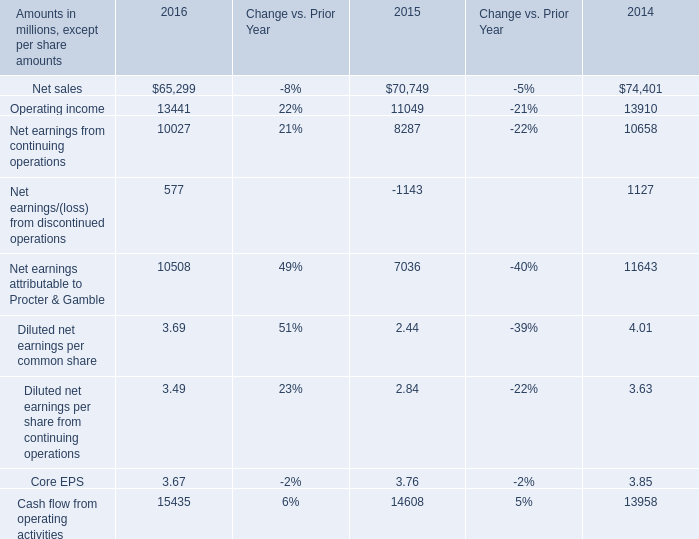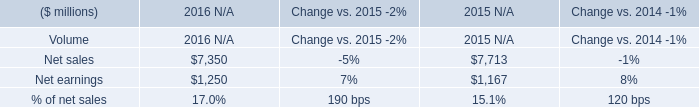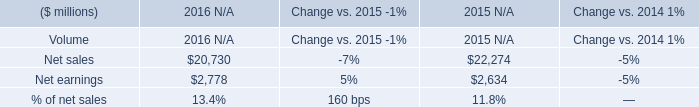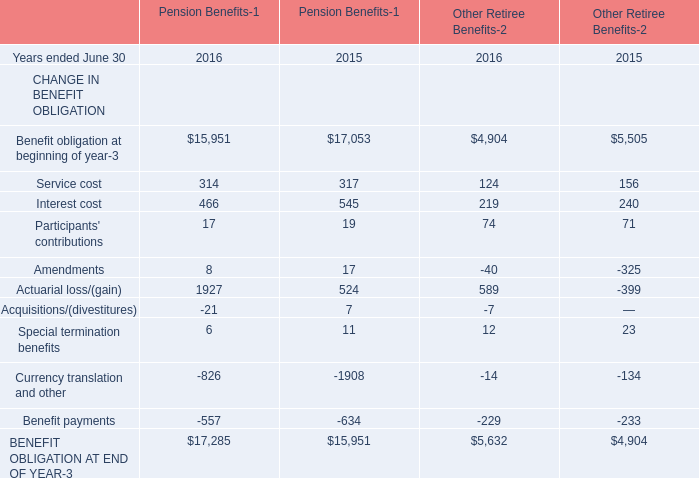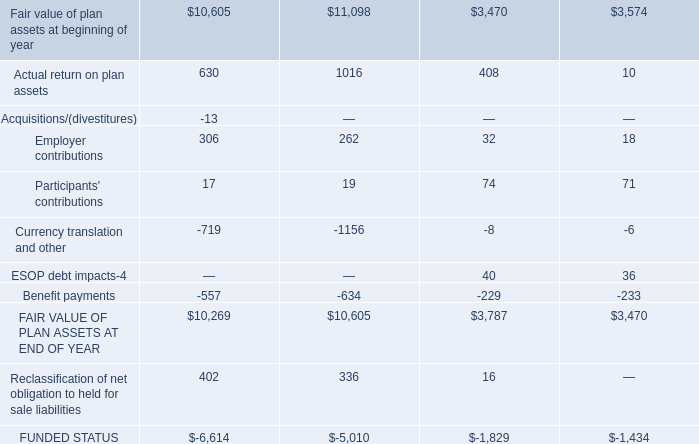what's the total amount of Net sales of 2016 N/A, and FAIR VALUE OF PLAN ASSETS AT END OF YEAR ? 
Computations: (7350.0 + 10605.0)
Answer: 17955.0. 